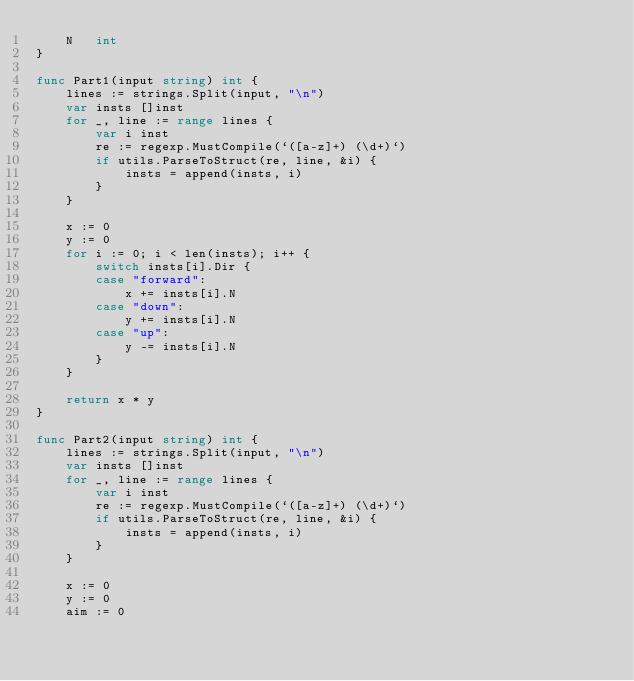Convert code to text. <code><loc_0><loc_0><loc_500><loc_500><_Go_>	N   int
}

func Part1(input string) int {
	lines := strings.Split(input, "\n")
	var insts []inst
	for _, line := range lines {
		var i inst
		re := regexp.MustCompile(`([a-z]+) (\d+)`)
		if utils.ParseToStruct(re, line, &i) {
			insts = append(insts, i)
		}
	}

	x := 0
	y := 0
	for i := 0; i < len(insts); i++ {
		switch insts[i].Dir {
		case "forward":
			x += insts[i].N
		case "down":
			y += insts[i].N
		case "up":
			y -= insts[i].N
		}
	}

	return x * y
}

func Part2(input string) int {
	lines := strings.Split(input, "\n")
	var insts []inst
	for _, line := range lines {
		var i inst
		re := regexp.MustCompile(`([a-z]+) (\d+)`)
		if utils.ParseToStruct(re, line, &i) {
			insts = append(insts, i)
		}
	}

	x := 0
	y := 0
	aim := 0</code> 